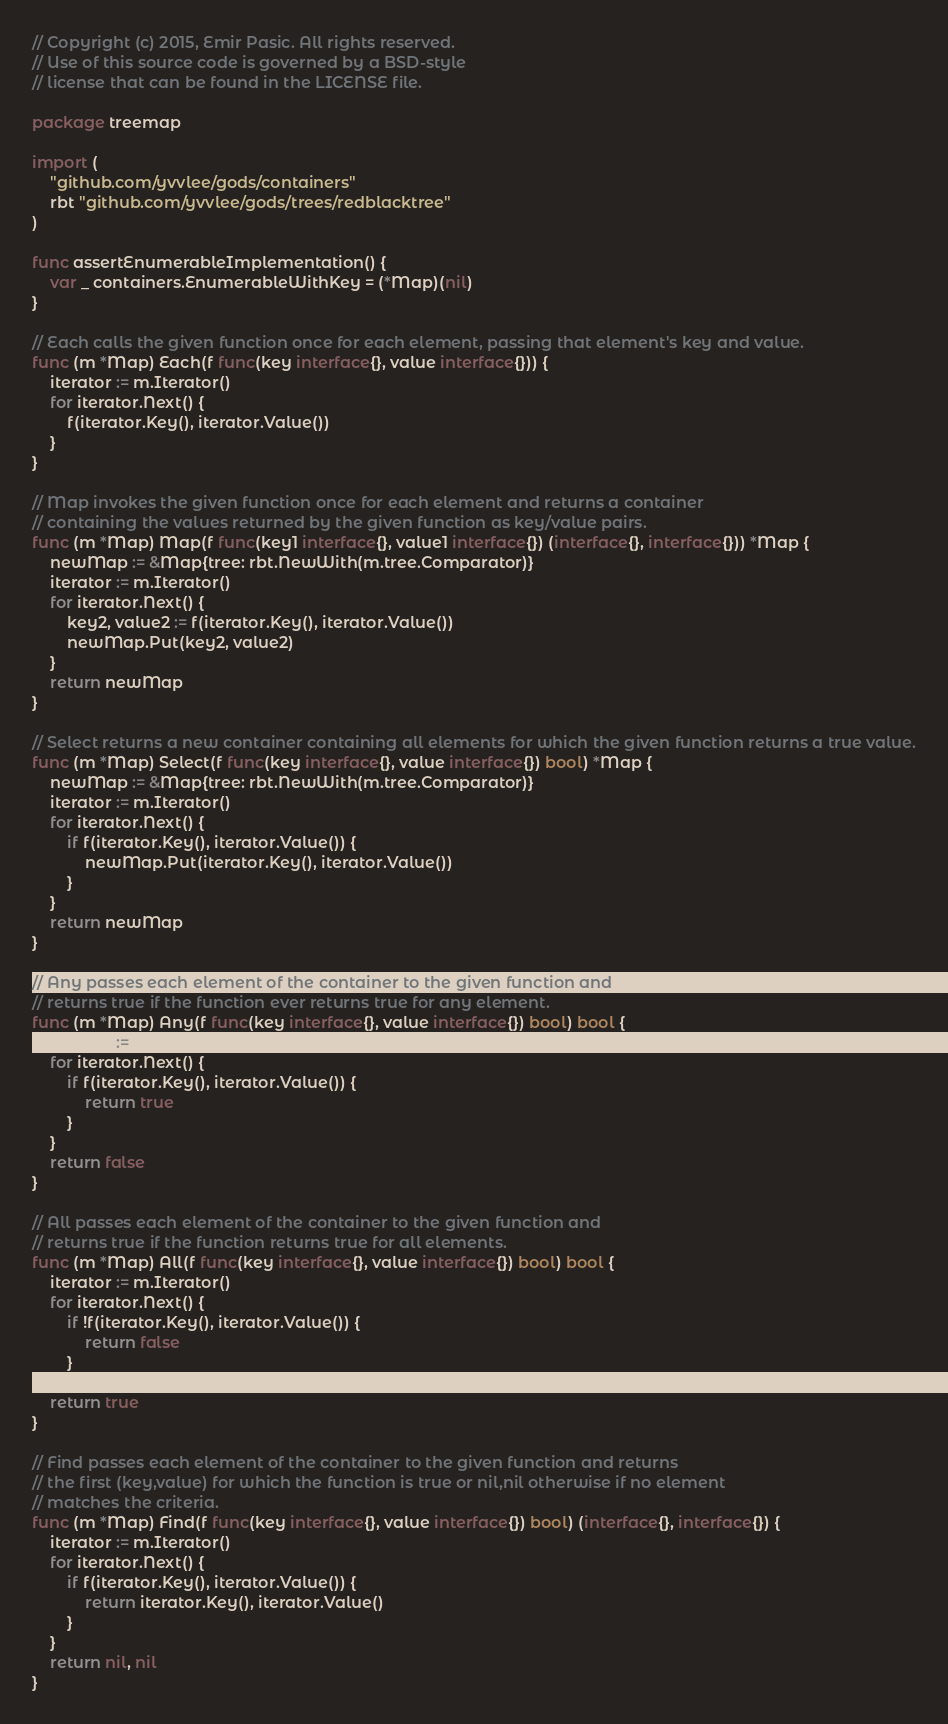<code> <loc_0><loc_0><loc_500><loc_500><_Go_>// Copyright (c) 2015, Emir Pasic. All rights reserved.
// Use of this source code is governed by a BSD-style
// license that can be found in the LICENSE file.

package treemap

import (
	"github.com/yvvlee/gods/containers"
	rbt "github.com/yvvlee/gods/trees/redblacktree"
)

func assertEnumerableImplementation() {
	var _ containers.EnumerableWithKey = (*Map)(nil)
}

// Each calls the given function once for each element, passing that element's key and value.
func (m *Map) Each(f func(key interface{}, value interface{})) {
	iterator := m.Iterator()
	for iterator.Next() {
		f(iterator.Key(), iterator.Value())
	}
}

// Map invokes the given function once for each element and returns a container
// containing the values returned by the given function as key/value pairs.
func (m *Map) Map(f func(key1 interface{}, value1 interface{}) (interface{}, interface{})) *Map {
	newMap := &Map{tree: rbt.NewWith(m.tree.Comparator)}
	iterator := m.Iterator()
	for iterator.Next() {
		key2, value2 := f(iterator.Key(), iterator.Value())
		newMap.Put(key2, value2)
	}
	return newMap
}

// Select returns a new container containing all elements for which the given function returns a true value.
func (m *Map) Select(f func(key interface{}, value interface{}) bool) *Map {
	newMap := &Map{tree: rbt.NewWith(m.tree.Comparator)}
	iterator := m.Iterator()
	for iterator.Next() {
		if f(iterator.Key(), iterator.Value()) {
			newMap.Put(iterator.Key(), iterator.Value())
		}
	}
	return newMap
}

// Any passes each element of the container to the given function and
// returns true if the function ever returns true for any element.
func (m *Map) Any(f func(key interface{}, value interface{}) bool) bool {
	iterator := m.Iterator()
	for iterator.Next() {
		if f(iterator.Key(), iterator.Value()) {
			return true
		}
	}
	return false
}

// All passes each element of the container to the given function and
// returns true if the function returns true for all elements.
func (m *Map) All(f func(key interface{}, value interface{}) bool) bool {
	iterator := m.Iterator()
	for iterator.Next() {
		if !f(iterator.Key(), iterator.Value()) {
			return false
		}
	}
	return true
}

// Find passes each element of the container to the given function and returns
// the first (key,value) for which the function is true or nil,nil otherwise if no element
// matches the criteria.
func (m *Map) Find(f func(key interface{}, value interface{}) bool) (interface{}, interface{}) {
	iterator := m.Iterator()
	for iterator.Next() {
		if f(iterator.Key(), iterator.Value()) {
			return iterator.Key(), iterator.Value()
		}
	}
	return nil, nil
}
</code> 